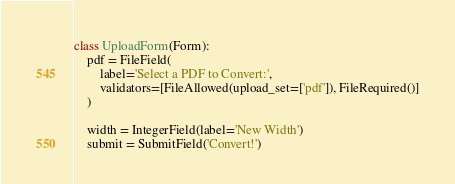<code> <loc_0><loc_0><loc_500><loc_500><_Python_>
class UploadForm(Form):
    pdf = FileField(
        label='Select a PDF to Convert:',
        validators=[FileAllowed(upload_set=['pdf']), FileRequired()]
    )

    width = IntegerField(label='New Width')
    submit = SubmitField('Convert!')
</code> 